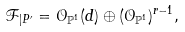Convert formula to latex. <formula><loc_0><loc_0><loc_500><loc_500>\mathcal { F } _ { | P ^ { \prime } } = \mathcal { O } _ { \mathbb { P } ^ { 1 } } ( d ) \oplus ( \mathcal { O } _ { \mathbb { P } ^ { 1 } } ) ^ { r - 1 } ,</formula> 